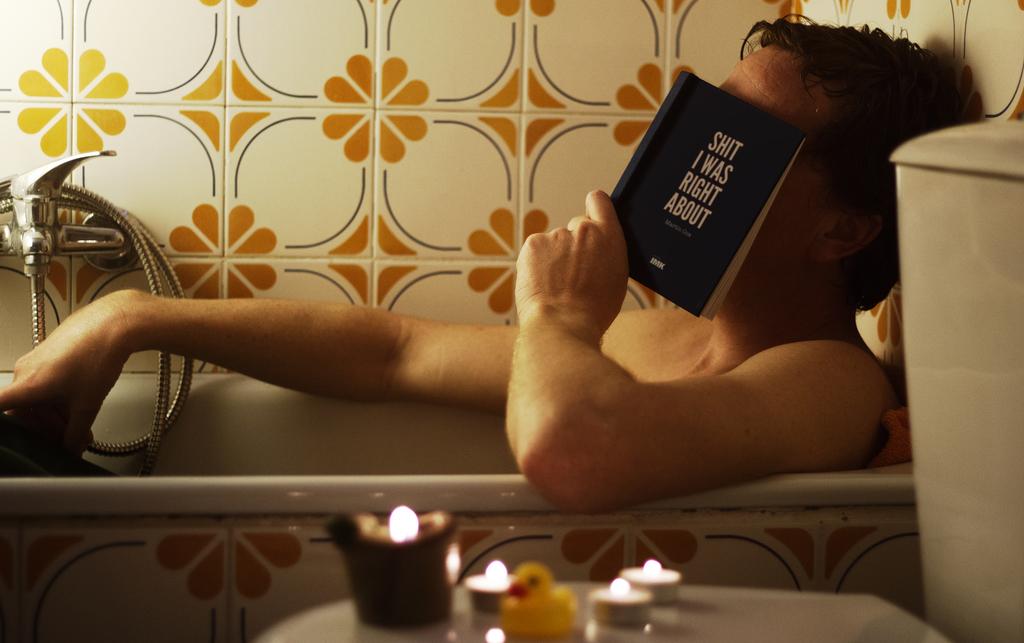What is the title of the book?
Provide a succinct answer. Shit i was right about. 